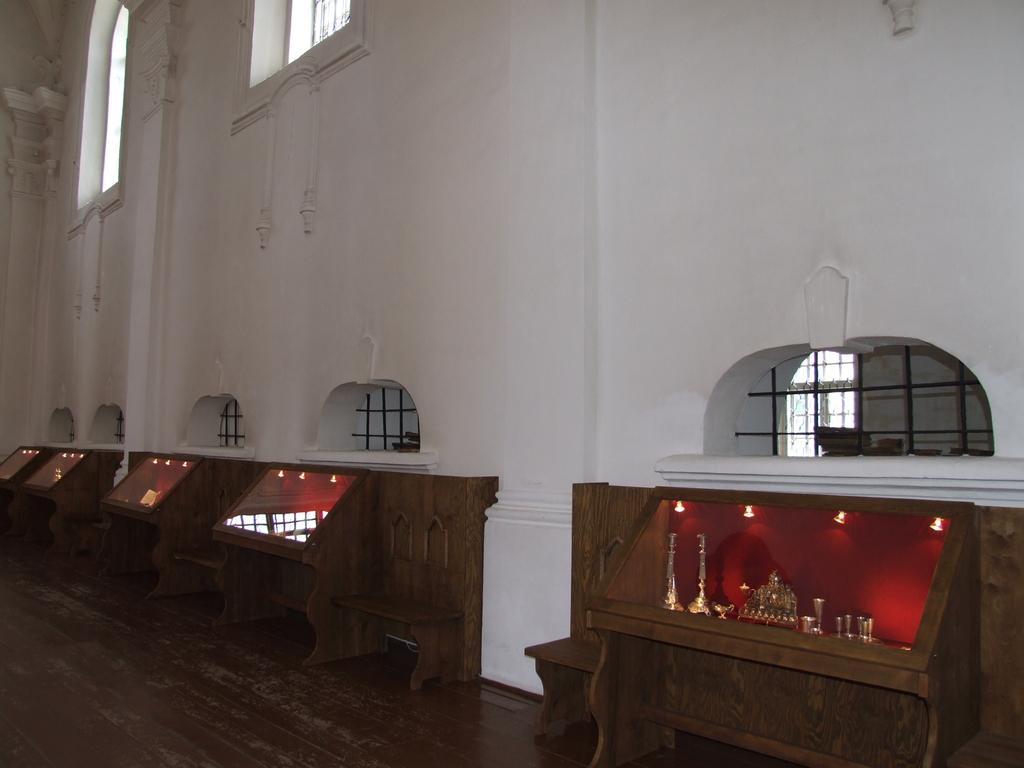What color is the wall in the image? The wall in the image is white. What can be seen on the wall in the image? There are windows in the image. What color are the desks in the image? The desks in the image are brown. What is on top of the desks in the image? There are objects on the desks. What provides illumination in the image? There are lights in the image. How does the sofa contribute to the pollution in the image? There is no sofa present in the image, and therefore it cannot contribute to any pollution. What type of rings are visible on the desks in the image? There are no rings visible on the desks in the image. 